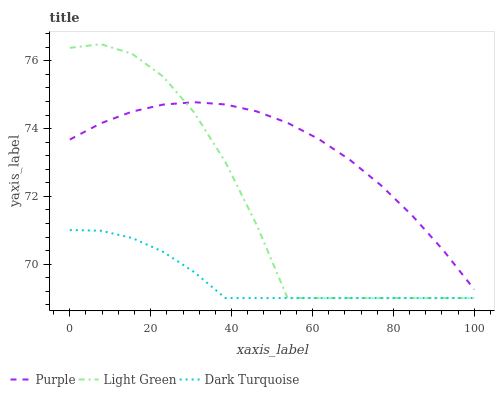Does Light Green have the minimum area under the curve?
Answer yes or no. No. Does Light Green have the maximum area under the curve?
Answer yes or no. No. Is Light Green the smoothest?
Answer yes or no. No. Is Dark Turquoise the roughest?
Answer yes or no. No. Does Dark Turquoise have the highest value?
Answer yes or no. No. Is Dark Turquoise less than Purple?
Answer yes or no. Yes. Is Purple greater than Dark Turquoise?
Answer yes or no. Yes. Does Dark Turquoise intersect Purple?
Answer yes or no. No. 